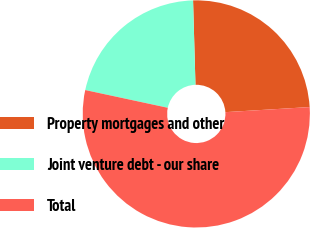Convert chart. <chart><loc_0><loc_0><loc_500><loc_500><pie_chart><fcel>Property mortgages and other<fcel>Joint venture debt - our share<fcel>Total<nl><fcel>24.49%<fcel>21.18%<fcel>54.33%<nl></chart> 